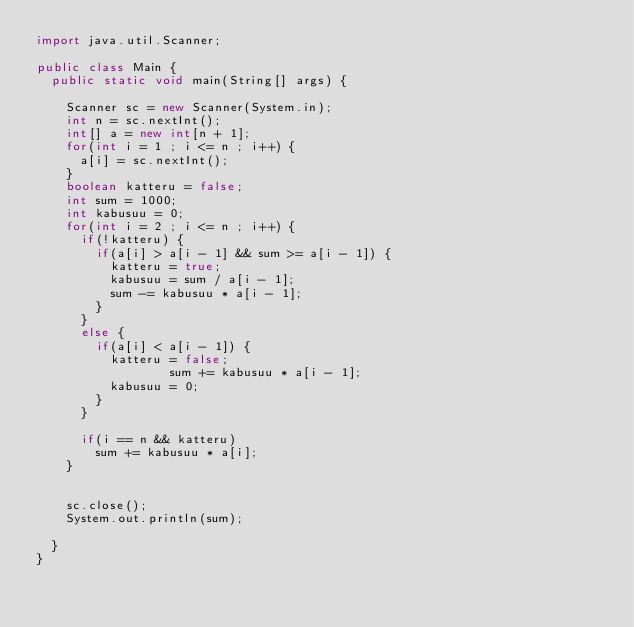Convert code to text. <code><loc_0><loc_0><loc_500><loc_500><_Java_>import java.util.Scanner;

public class Main {
	public static void main(String[] args) {

		Scanner sc = new Scanner(System.in);
		int n = sc.nextInt();
		int[] a = new int[n + 1];
		for(int i = 1 ; i <= n ; i++) {
			a[i] = sc.nextInt();
		}
		boolean katteru = false;
		int sum = 1000;
		int kabusuu = 0;
		for(int i = 2 ; i <= n ; i++) {
			if(!katteru) {
				if(a[i] > a[i - 1] && sum >= a[i - 1]) {
					katteru = true;
					kabusuu = sum / a[i - 1];
					sum -= kabusuu * a[i - 1];
				}
			}
			else {
				if(a[i] < a[i - 1]) {
					katteru = false;
                  sum += kabusuu * a[i - 1];
					kabusuu = 0;
				}
			}

			if(i == n && katteru)
				sum += kabusuu * a[i];
		}


		sc.close();
		System.out.println(sum);

	}
}

</code> 